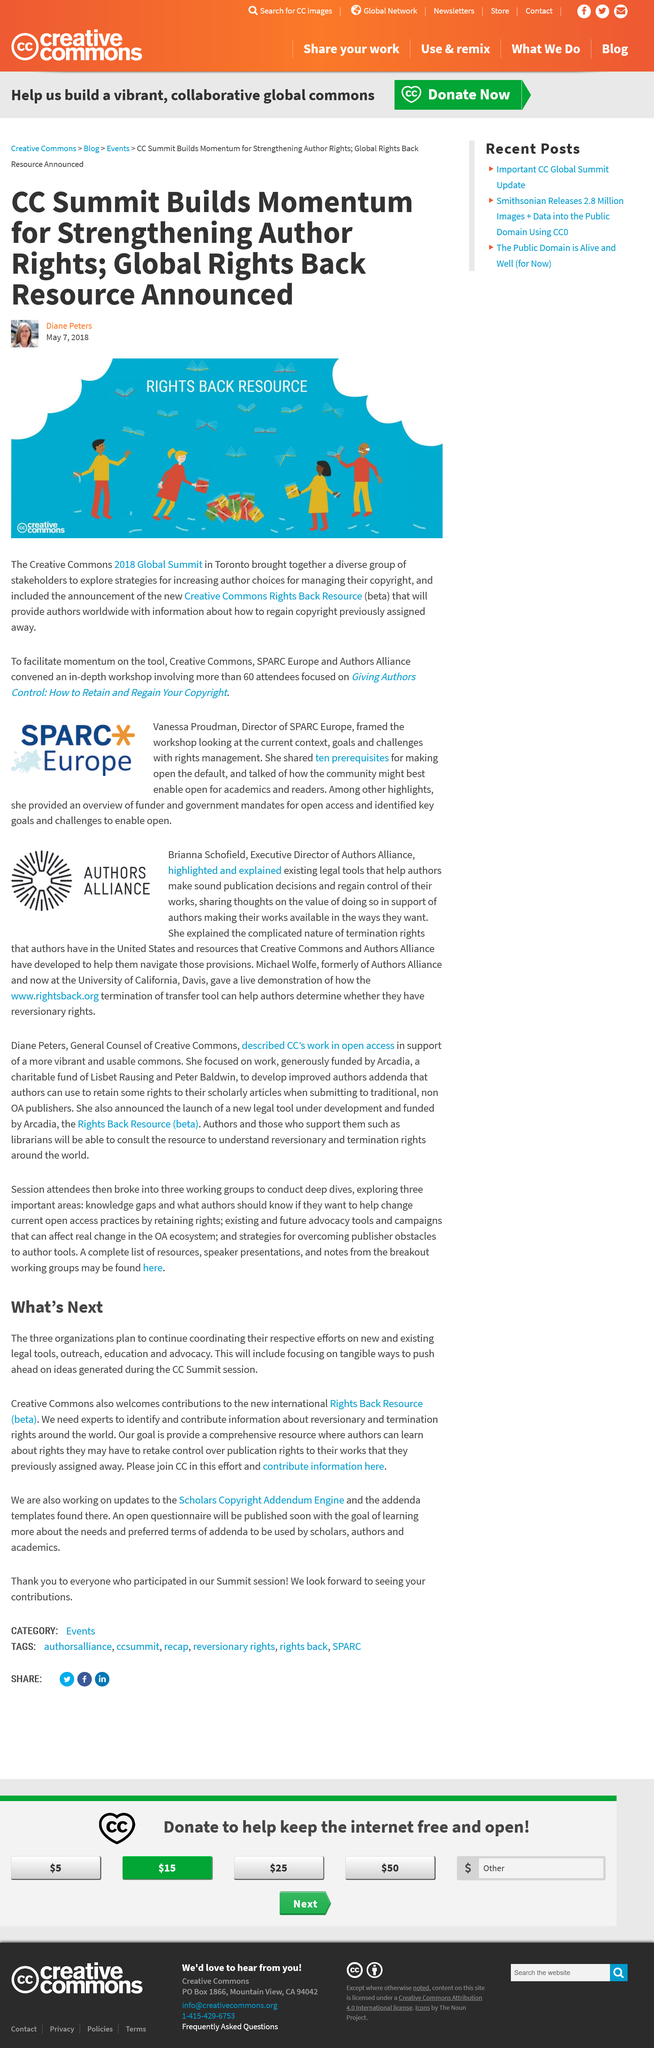Draw attention to some important aspects in this diagram. Brianna Schofield is the Executive Director of Authors Alliance, an organization focused on promoting and protecting the rights of authors in the digital age. Vanessa Proudman framed the workshop by examining the current context, objectives, and challenges related to rights management. The person who was previously with Authors Alliance and is now at the University of California is named Wolfe. Vanessa Proudman highlighted the importance of open access and highlighted key goals and challenges to achieve it, as well as the role of funders and government mandates in promoting open access. The person who is formerly of Authors Alliance and is now at the University of California is named Michael. 